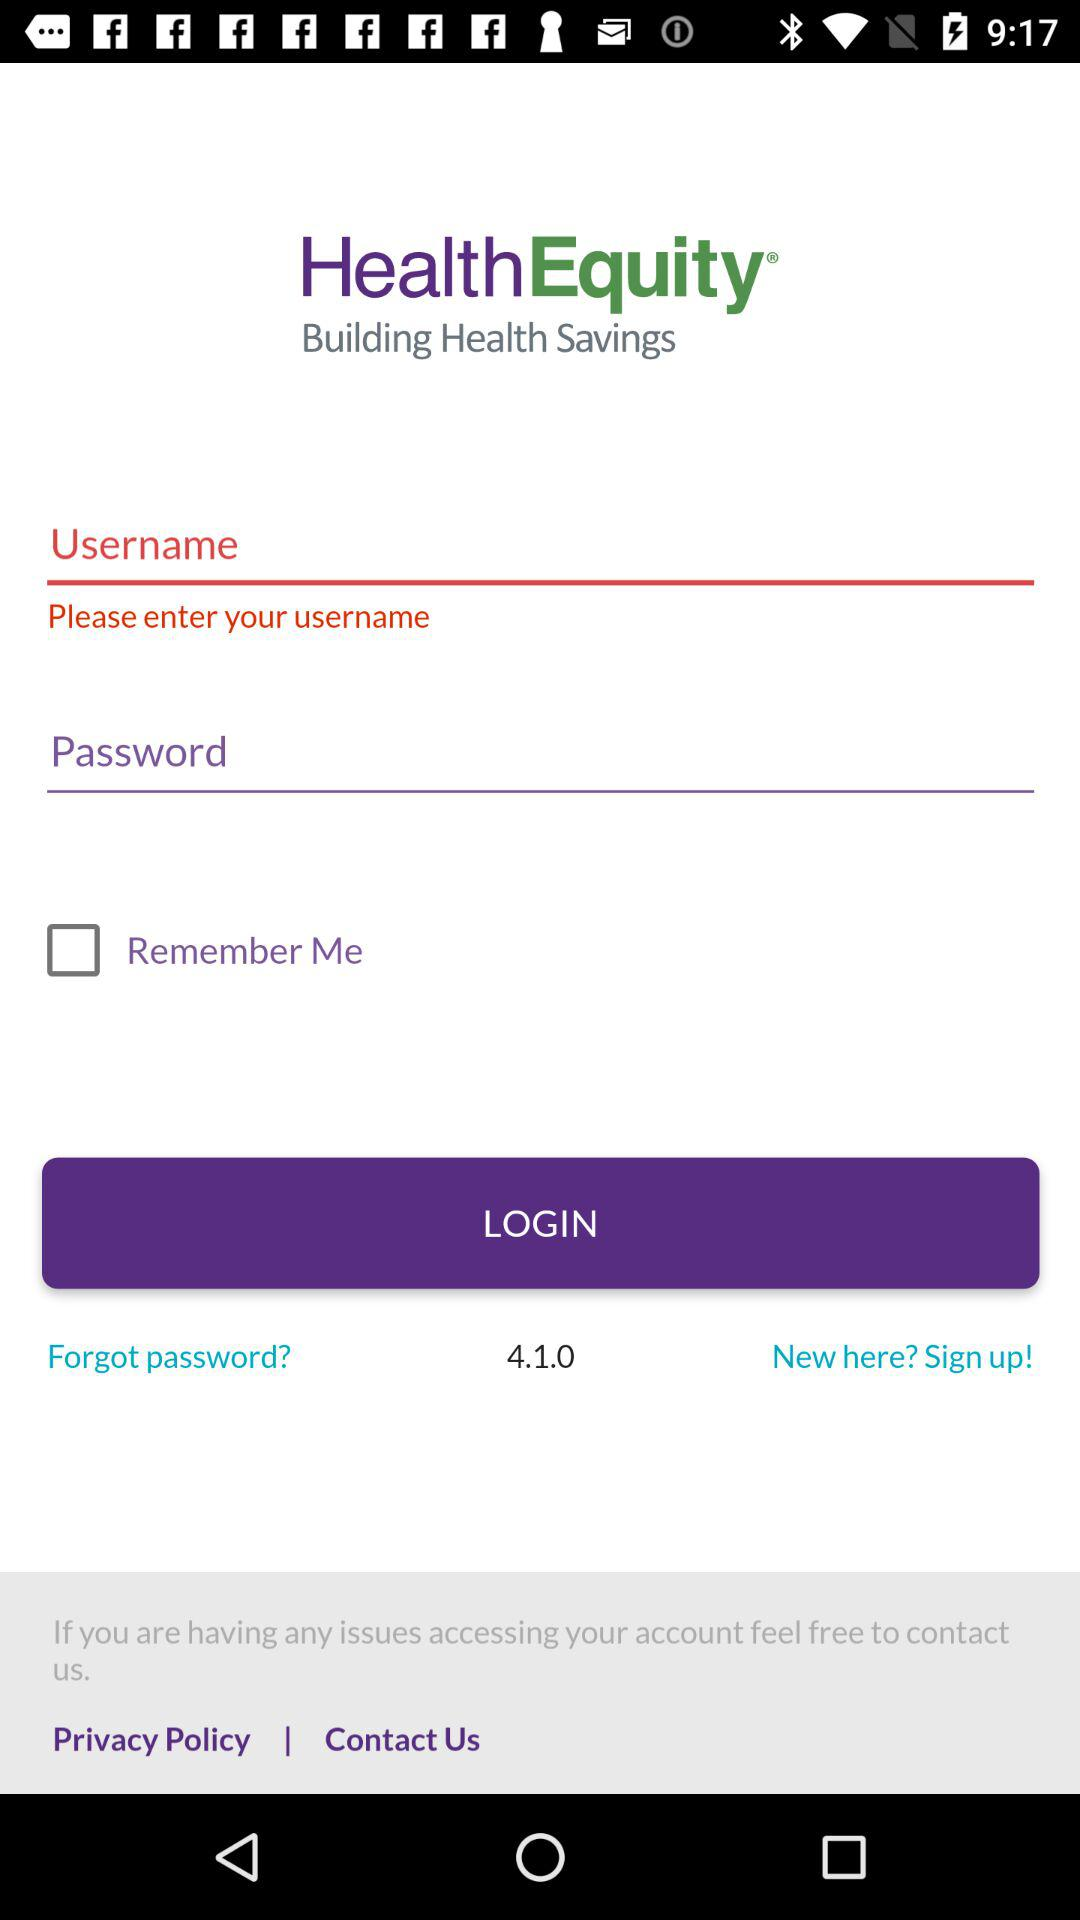What is the status of "Remember Me"? The status is "off". 